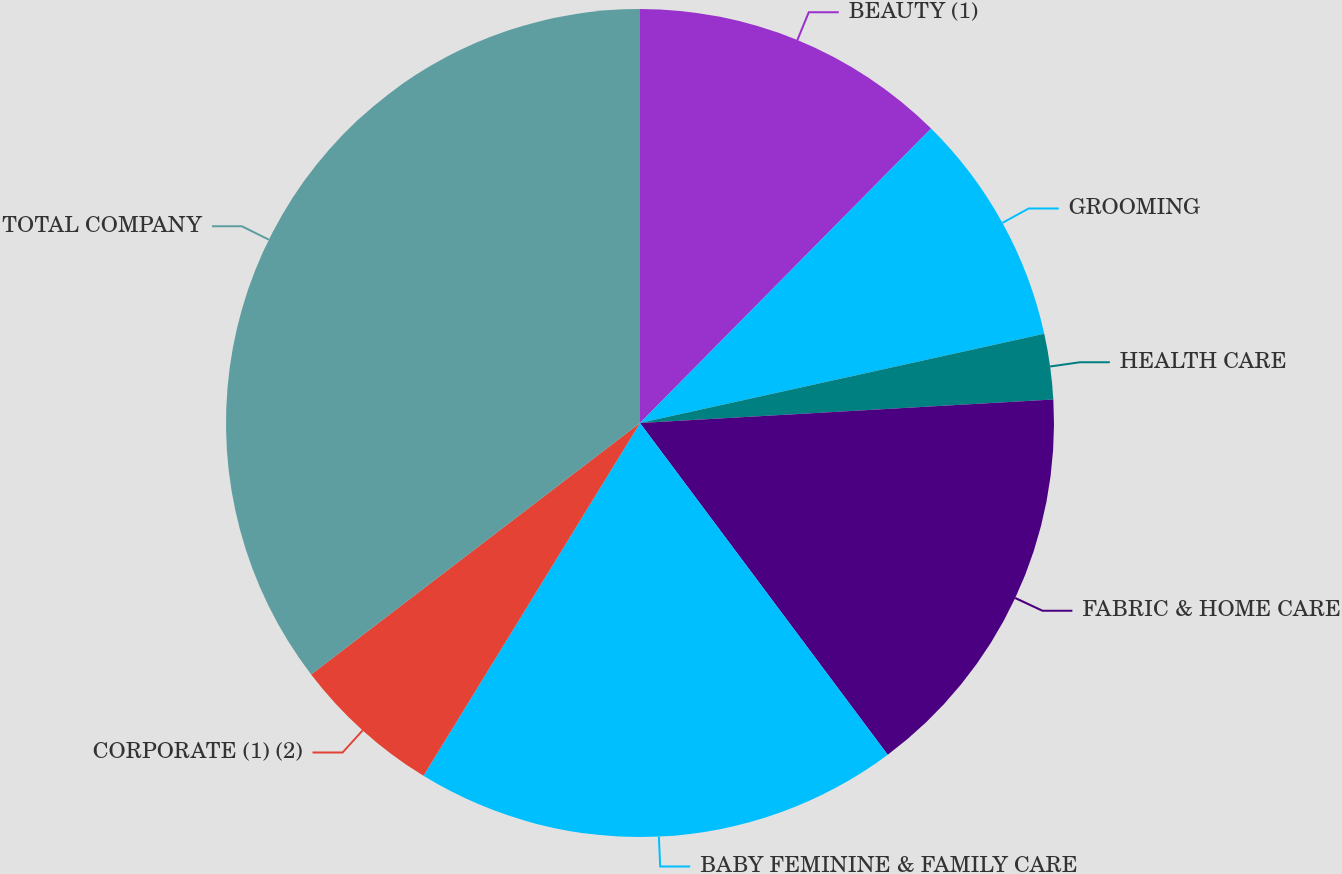Convert chart. <chart><loc_0><loc_0><loc_500><loc_500><pie_chart><fcel>BEAUTY (1)<fcel>GROOMING<fcel>HEALTH CARE<fcel>FABRIC & HOME CARE<fcel>BABY FEMININE & FAMILY CARE<fcel>CORPORATE (1) (2)<fcel>TOTAL COMPANY<nl><fcel>12.41%<fcel>9.13%<fcel>2.56%<fcel>15.69%<fcel>18.97%<fcel>5.85%<fcel>35.39%<nl></chart> 